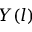Convert formula to latex. <formula><loc_0><loc_0><loc_500><loc_500>Y ( l )</formula> 